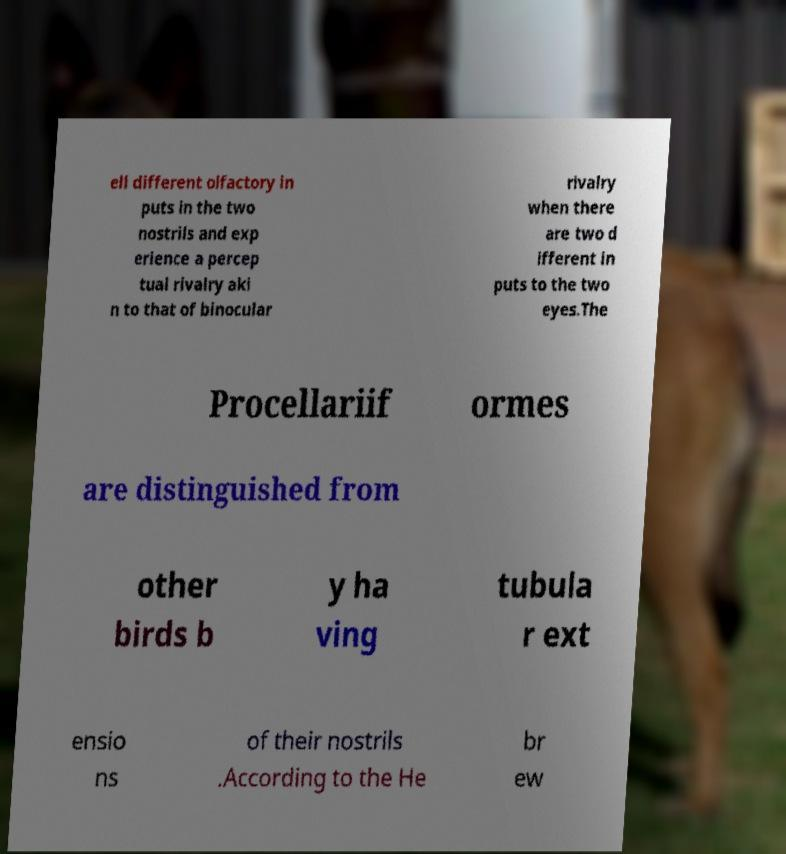Can you accurately transcribe the text from the provided image for me? ell different olfactory in puts in the two nostrils and exp erience a percep tual rivalry aki n to that of binocular rivalry when there are two d ifferent in puts to the two eyes.The Procellariif ormes are distinguished from other birds b y ha ving tubula r ext ensio ns of their nostrils .According to the He br ew 